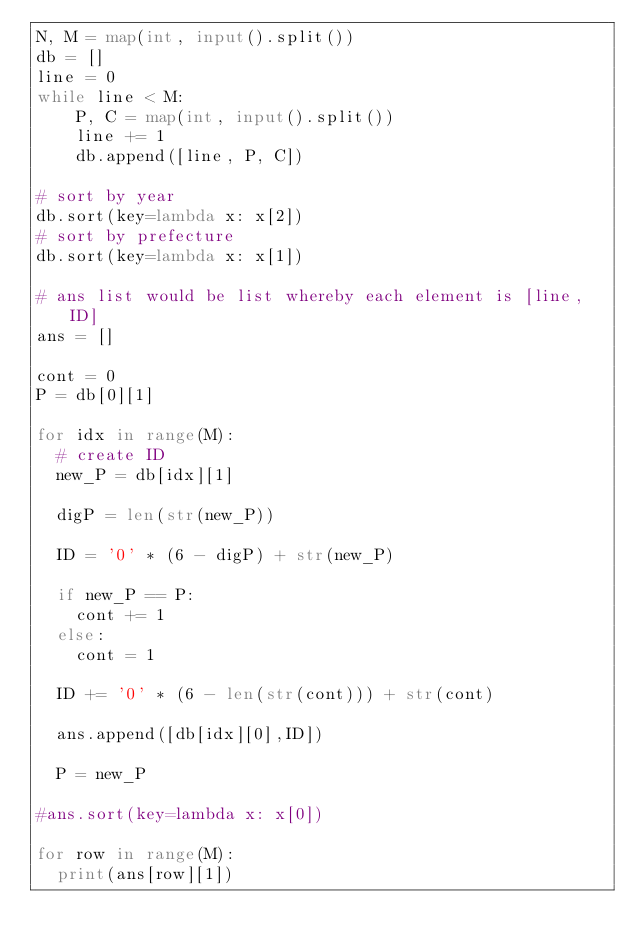Convert code to text. <code><loc_0><loc_0><loc_500><loc_500><_Python_>N, M = map(int, input().split())
db = []
line = 0
while line < M:
    P, C = map(int, input().split())
    line += 1
    db.append([line, P, C])

# sort by year    
db.sort(key=lambda x: x[2])
# sort by prefecture
db.sort(key=lambda x: x[1])

# ans list would be list whereby each element is [line, ID]
ans = []

cont = 0
P = db[0][1]

for idx in range(M):
  # create ID
  new_P = db[idx][1]
  
  digP = len(str(new_P))
  
  ID = '0' * (6 - digP) + str(new_P)
  
  if new_P == P:
    cont += 1
  else:
    cont = 1
    
  ID += '0' * (6 - len(str(cont))) + str(cont)
  
  ans.append([db[idx][0],ID])
  
  P = new_P

#ans.sort(key=lambda x: x[0])

for row in range(M):
  print(ans[row][1])
    </code> 